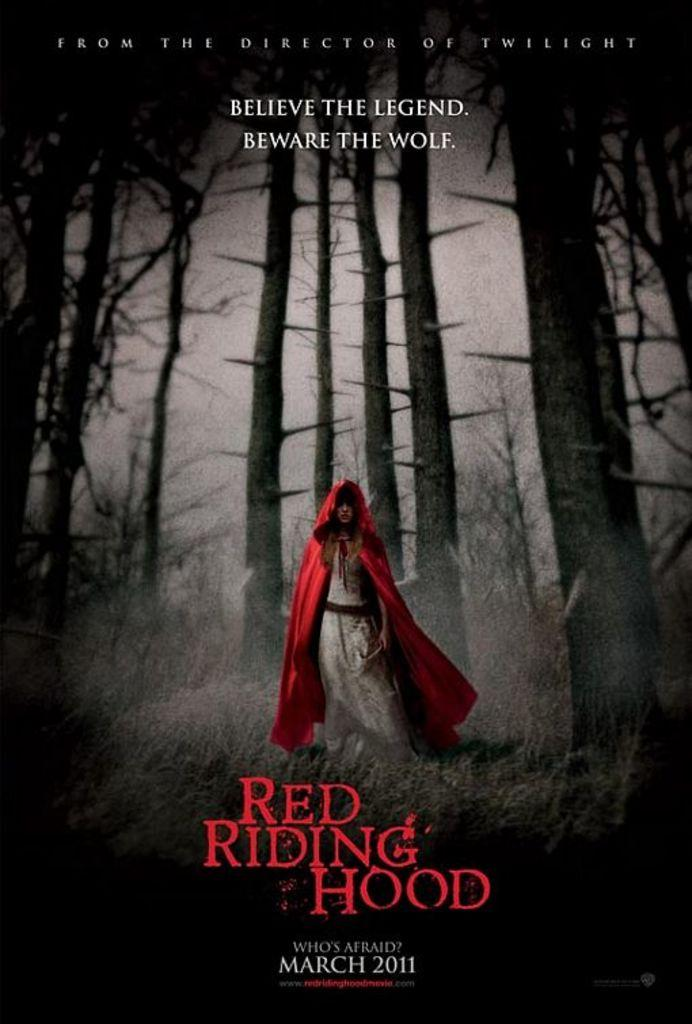<image>
Create a compact narrative representing the image presented. An ad for Red Riding Hood, released in 2011, features dark woods. 